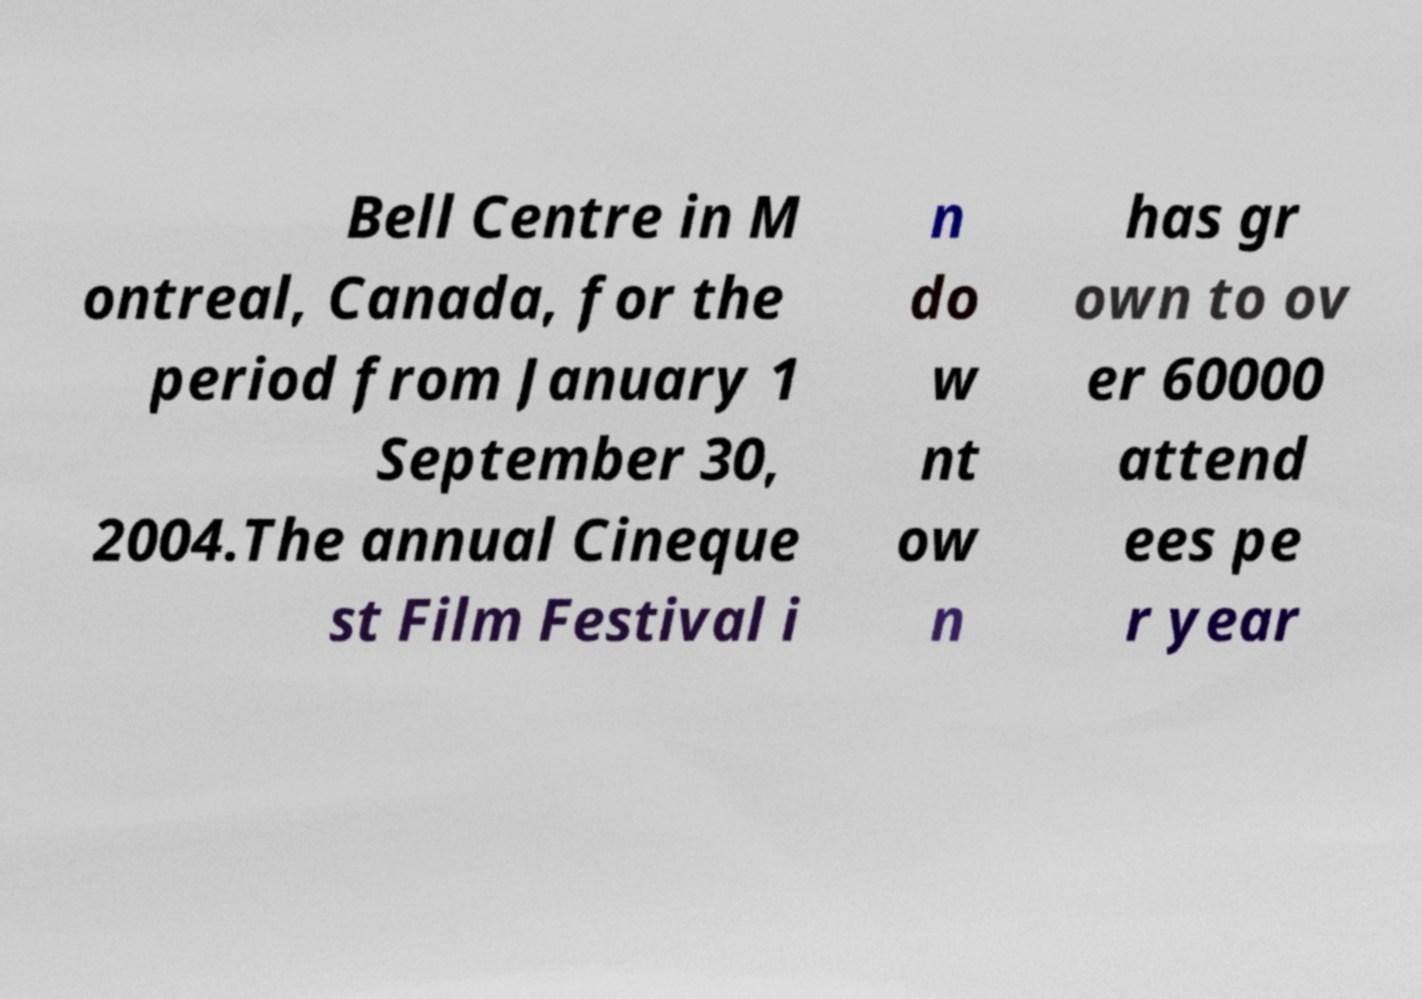For documentation purposes, I need the text within this image transcribed. Could you provide that? Bell Centre in M ontreal, Canada, for the period from January 1 September 30, 2004.The annual Cineque st Film Festival i n do w nt ow n has gr own to ov er 60000 attend ees pe r year 